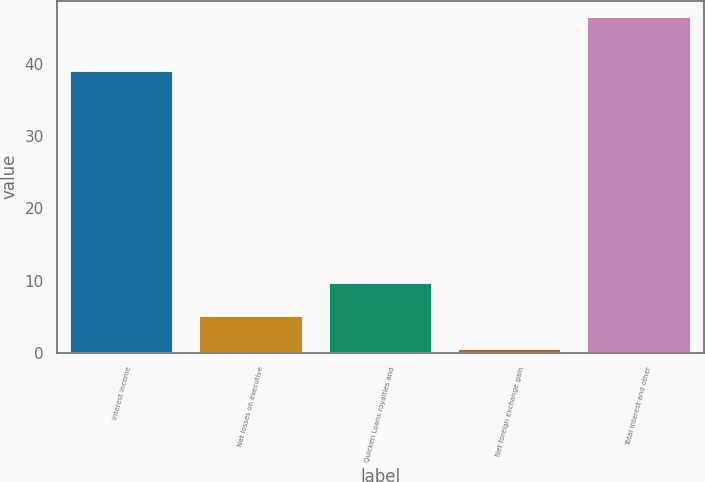<chart> <loc_0><loc_0><loc_500><loc_500><bar_chart><fcel>Interest income<fcel>Net losses on executive<fcel>Quicken Loans royalties and<fcel>Net foreign exchange gain<fcel>Total interest and other<nl><fcel>39<fcel>5.1<fcel>9.7<fcel>0.5<fcel>46.5<nl></chart> 